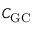<formula> <loc_0><loc_0><loc_500><loc_500>C _ { G C }</formula> 